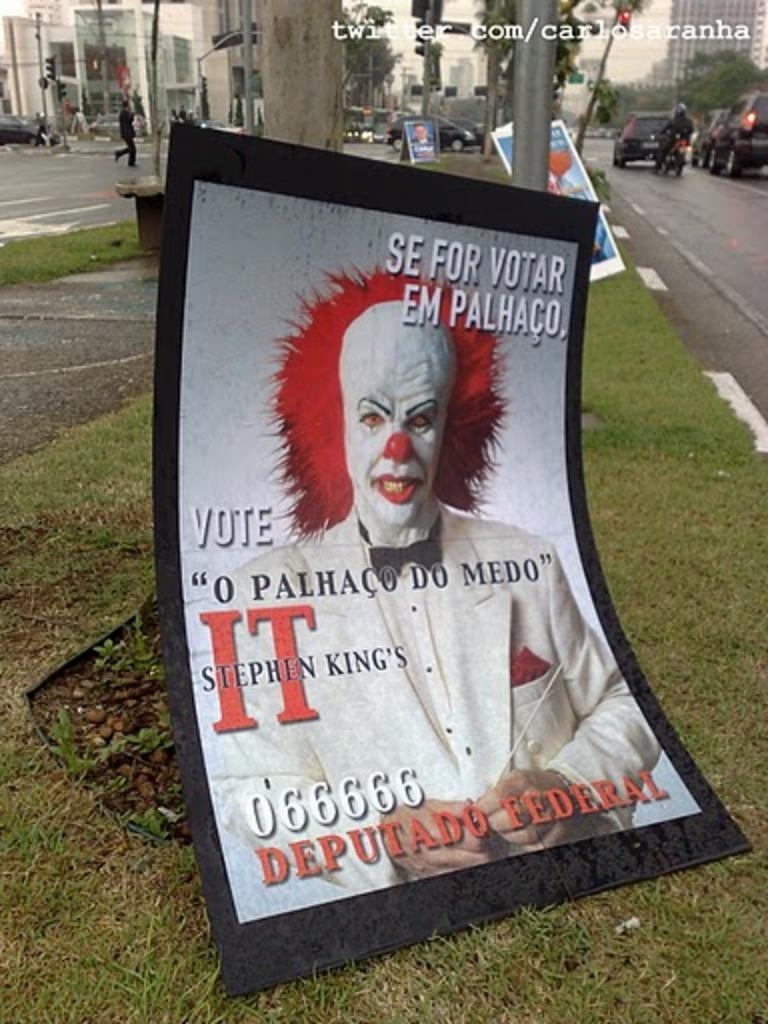<image>
Present a compact description of the photo's key features. Poster showing a clown for Stephen King's It movie. 